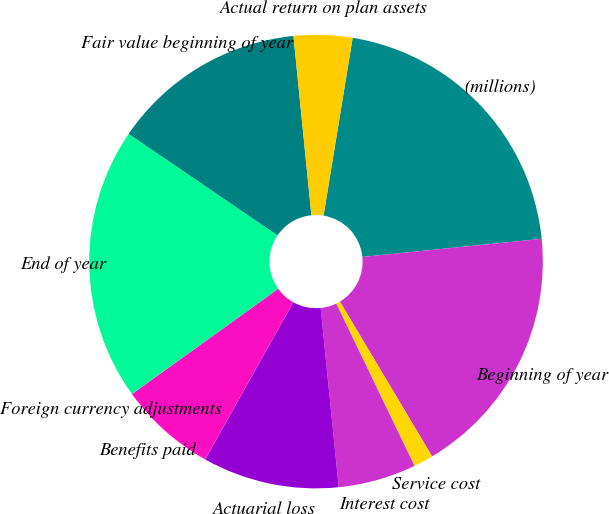<chart> <loc_0><loc_0><loc_500><loc_500><pie_chart><fcel>(millions)<fcel>Beginning of year<fcel>Service cost<fcel>Interest cost<fcel>Actuarial loss<fcel>Benefits paid<fcel>Foreign currency adjustments<fcel>End of year<fcel>Fair value beginning of year<fcel>Actual return on plan assets<nl><fcel>20.82%<fcel>18.05%<fcel>1.4%<fcel>5.56%<fcel>9.72%<fcel>6.95%<fcel>0.01%<fcel>19.44%<fcel>13.89%<fcel>4.17%<nl></chart> 